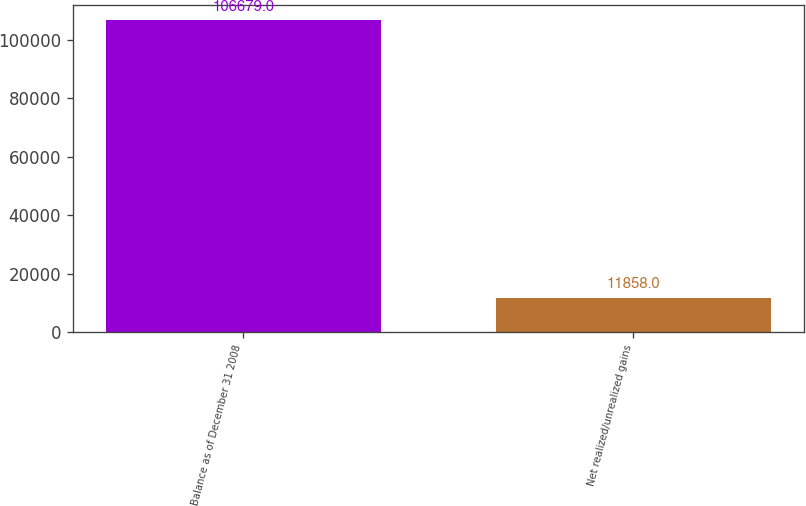Convert chart to OTSL. <chart><loc_0><loc_0><loc_500><loc_500><bar_chart><fcel>Balance as of December 31 2008<fcel>Net realized/unrealized gains<nl><fcel>106679<fcel>11858<nl></chart> 